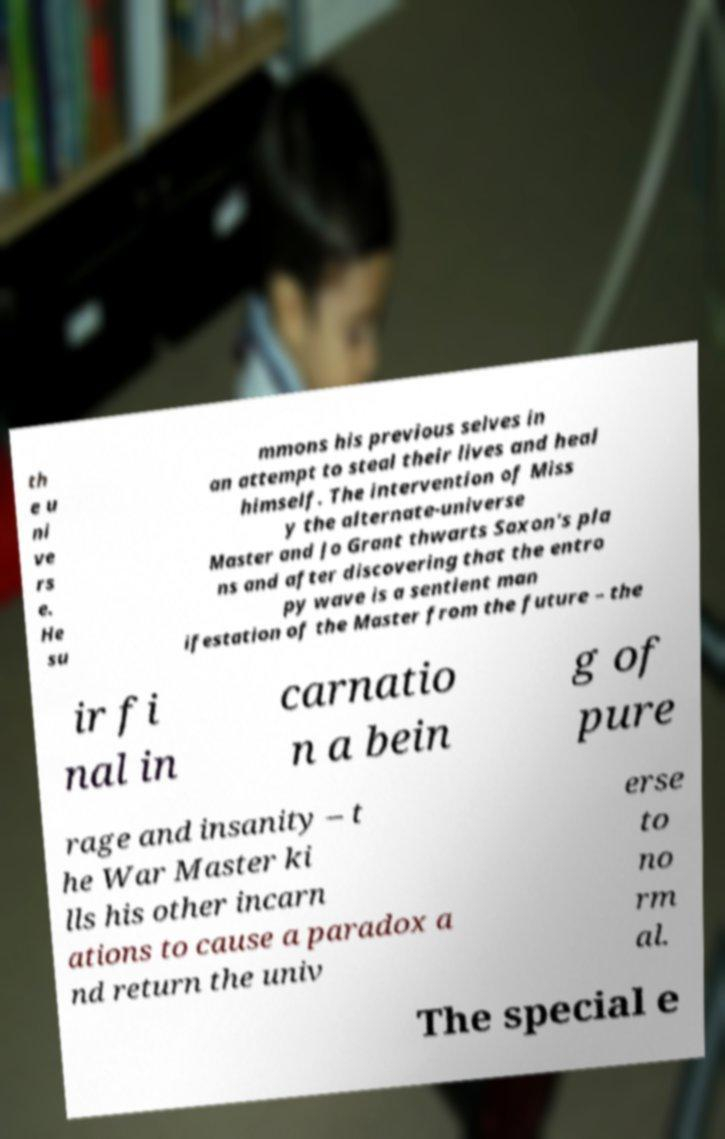I need the written content from this picture converted into text. Can you do that? th e u ni ve rs e. He su mmons his previous selves in an attempt to steal their lives and heal himself. The intervention of Miss y the alternate-universe Master and Jo Grant thwarts Saxon's pla ns and after discovering that the entro py wave is a sentient man ifestation of the Master from the future – the ir fi nal in carnatio n a bein g of pure rage and insanity – t he War Master ki lls his other incarn ations to cause a paradox a nd return the univ erse to no rm al. The special e 